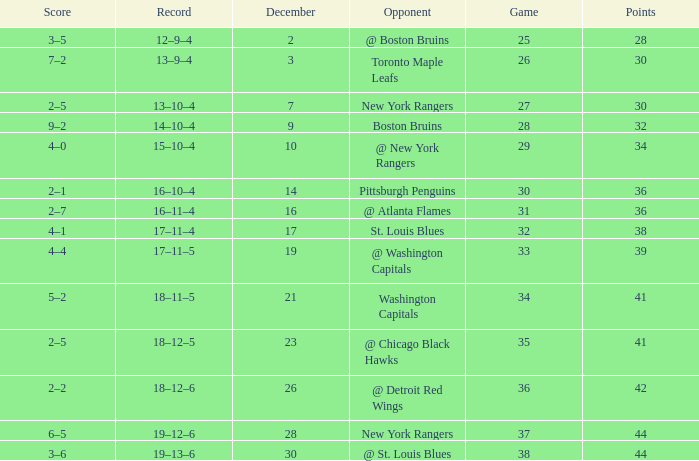Could you help me parse every detail presented in this table? {'header': ['Score', 'Record', 'December', 'Opponent', 'Game', 'Points'], 'rows': [['3–5', '12–9–4', '2', '@ Boston Bruins', '25', '28'], ['7–2', '13–9–4', '3', 'Toronto Maple Leafs', '26', '30'], ['2–5', '13–10–4', '7', 'New York Rangers', '27', '30'], ['9–2', '14–10–4', '9', 'Boston Bruins', '28', '32'], ['4–0', '15–10–4', '10', '@ New York Rangers', '29', '34'], ['2–1', '16–10–4', '14', 'Pittsburgh Penguins', '30', '36'], ['2–7', '16–11–4', '16', '@ Atlanta Flames', '31', '36'], ['4–1', '17–11–4', '17', 'St. Louis Blues', '32', '38'], ['4–4', '17–11–5', '19', '@ Washington Capitals', '33', '39'], ['5–2', '18–11–5', '21', 'Washington Capitals', '34', '41'], ['2–5', '18–12–5', '23', '@ Chicago Black Hawks', '35', '41'], ['2–2', '18–12–6', '26', '@ Detroit Red Wings', '36', '42'], ['6–5', '19–12–6', '28', 'New York Rangers', '37', '44'], ['3–6', '19–13–6', '30', '@ St. Louis Blues', '38', '44']]} Which Game has a Score of 4–1? 32.0. 